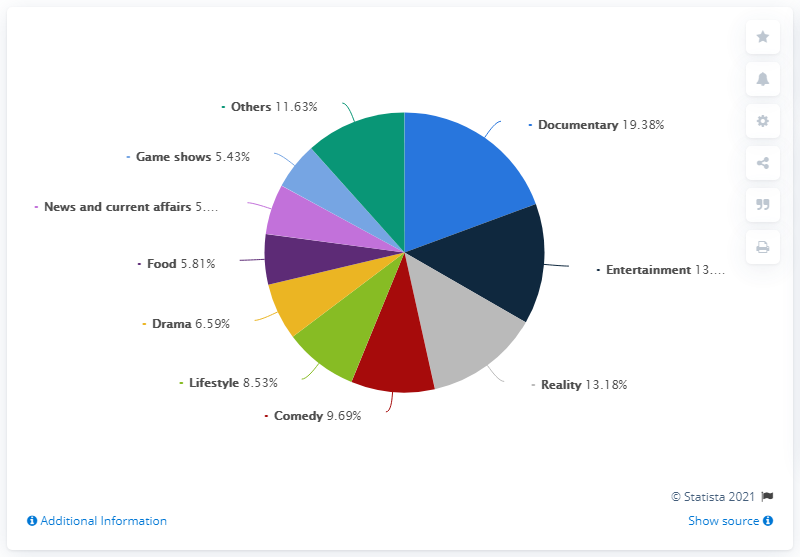Can you tell me which genres make up the smallest portions of this chart? The genres with the smallest portions are 'Game shows,' 'News and current affairs,' and 'Food,' each representing less than 6% of the chart. 